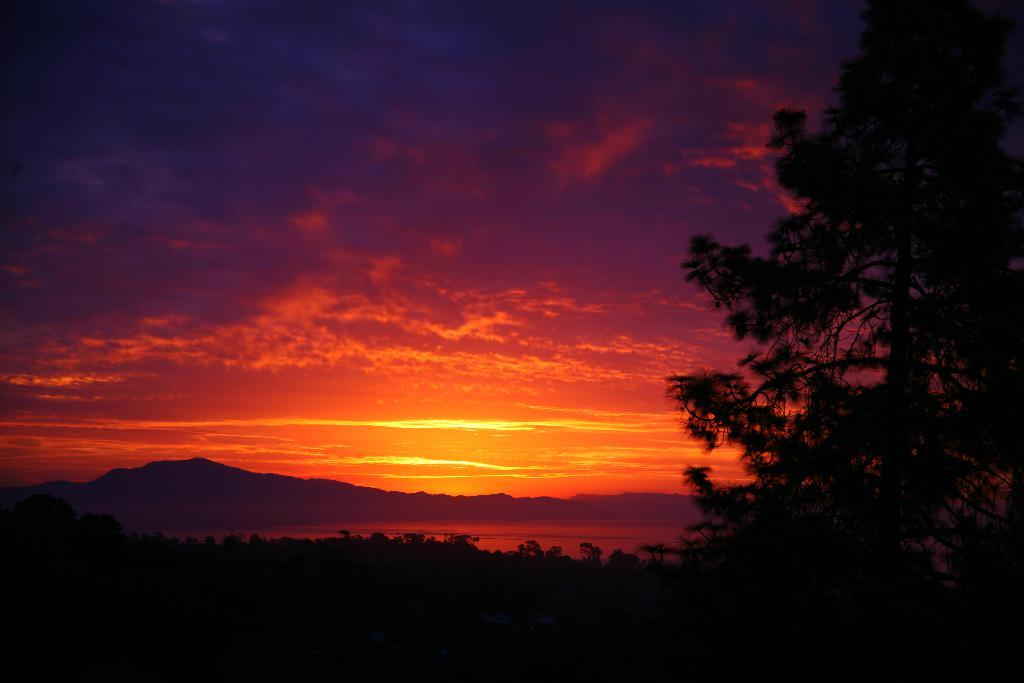What can be seen in the sky in the image? The sky with clouds is visible in the image. Can you describe the sky in the image? The sky is visible in the image. What type of landscape features are present in the image? There are hills in the image. What other natural elements can be seen in the image? Trees and water are visible in the image. How many friends are visible in the image? There are no friends present in the image; it features a landscape with hills, trees, water, and a sky with clouds. 